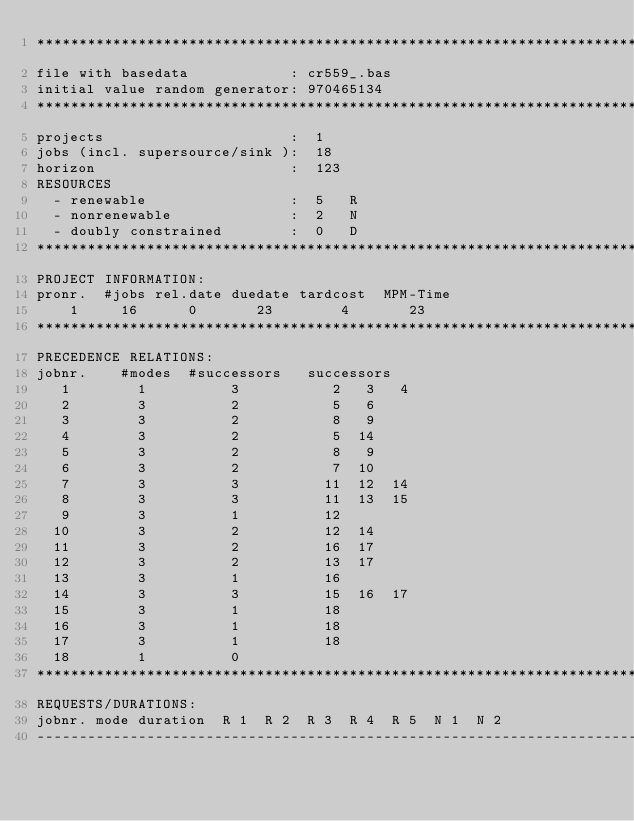Convert code to text. <code><loc_0><loc_0><loc_500><loc_500><_ObjectiveC_>************************************************************************
file with basedata            : cr559_.bas
initial value random generator: 970465134
************************************************************************
projects                      :  1
jobs (incl. supersource/sink ):  18
horizon                       :  123
RESOURCES
  - renewable                 :  5   R
  - nonrenewable              :  2   N
  - doubly constrained        :  0   D
************************************************************************
PROJECT INFORMATION:
pronr.  #jobs rel.date duedate tardcost  MPM-Time
    1     16      0       23        4       23
************************************************************************
PRECEDENCE RELATIONS:
jobnr.    #modes  #successors   successors
   1        1          3           2   3   4
   2        3          2           5   6
   3        3          2           8   9
   4        3          2           5  14
   5        3          2           8   9
   6        3          2           7  10
   7        3          3          11  12  14
   8        3          3          11  13  15
   9        3          1          12
  10        3          2          12  14
  11        3          2          16  17
  12        3          2          13  17
  13        3          1          16
  14        3          3          15  16  17
  15        3          1          18
  16        3          1          18
  17        3          1          18
  18        1          0        
************************************************************************
REQUESTS/DURATIONS:
jobnr. mode duration  R 1  R 2  R 3  R 4  R 5  N 1  N 2
------------------------------------------------------------------------</code> 